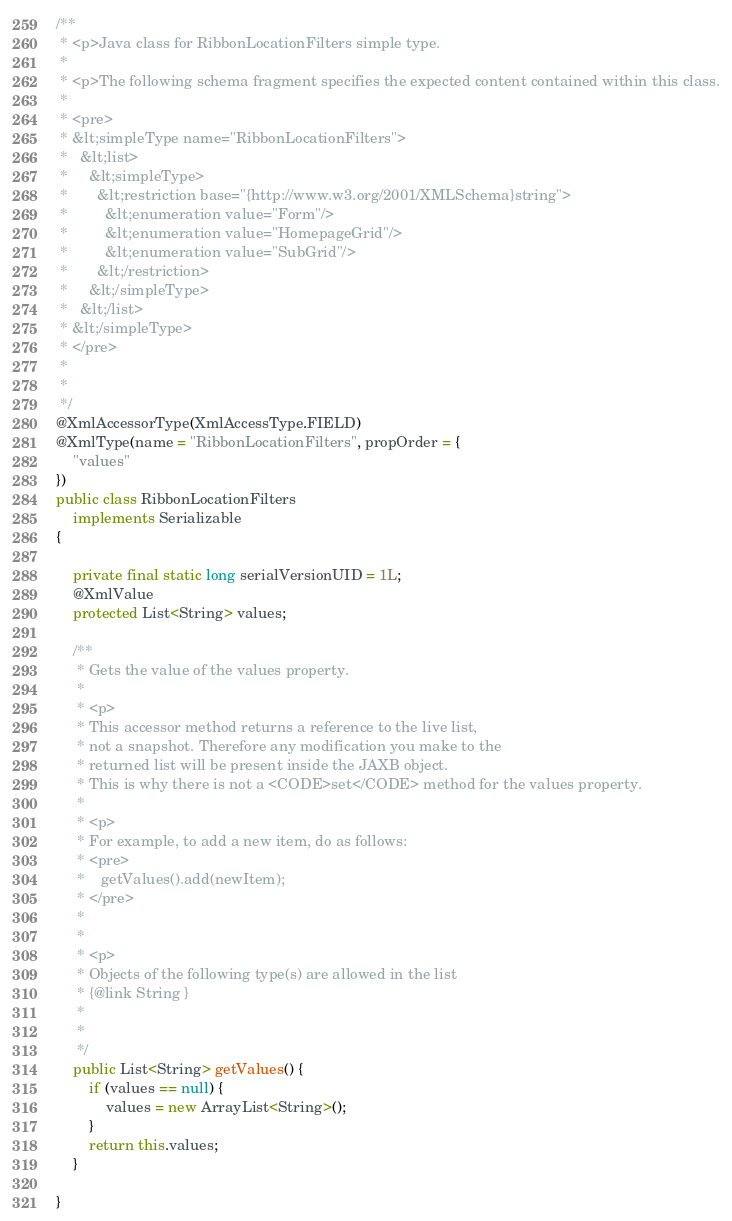<code> <loc_0><loc_0><loc_500><loc_500><_Java_>
/**
 * <p>Java class for RibbonLocationFilters simple type.
 * 
 * <p>The following schema fragment specifies the expected content contained within this class.
 * 
 * <pre>
 * &lt;simpleType name="RibbonLocationFilters">
 *   &lt;list>
 *     &lt;simpleType>
 *       &lt;restriction base="{http://www.w3.org/2001/XMLSchema}string">
 *         &lt;enumeration value="Form"/>
 *         &lt;enumeration value="HomepageGrid"/>
 *         &lt;enumeration value="SubGrid"/>
 *       &lt;/restriction>
 *     &lt;/simpleType>
 *   &lt;/list>
 * &lt;/simpleType>
 * </pre>
 * 
 * 
 */
@XmlAccessorType(XmlAccessType.FIELD)
@XmlType(name = "RibbonLocationFilters", propOrder = {
    "values"
})
public class RibbonLocationFilters
    implements Serializable
{

    private final static long serialVersionUID = 1L;
    @XmlValue
    protected List<String> values;

    /**
     * Gets the value of the values property.
     * 
     * <p>
     * This accessor method returns a reference to the live list,
     * not a snapshot. Therefore any modification you make to the
     * returned list will be present inside the JAXB object.
     * This is why there is not a <CODE>set</CODE> method for the values property.
     * 
     * <p>
     * For example, to add a new item, do as follows:
     * <pre>
     *    getValues().add(newItem);
     * </pre>
     * 
     * 
     * <p>
     * Objects of the following type(s) are allowed in the list
     * {@link String }
     * 
     * 
     */
    public List<String> getValues() {
        if (values == null) {
            values = new ArrayList<String>();
        }
        return this.values;
    }

}
</code> 